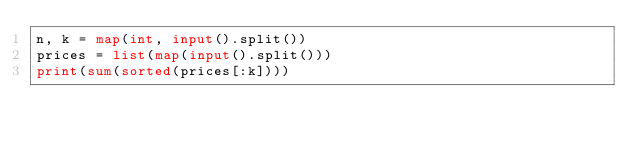Convert code to text. <code><loc_0><loc_0><loc_500><loc_500><_Python_>n, k = map(int, input().split())
prices = list(map(input().split()))
print(sum(sorted(prices[:k])))</code> 